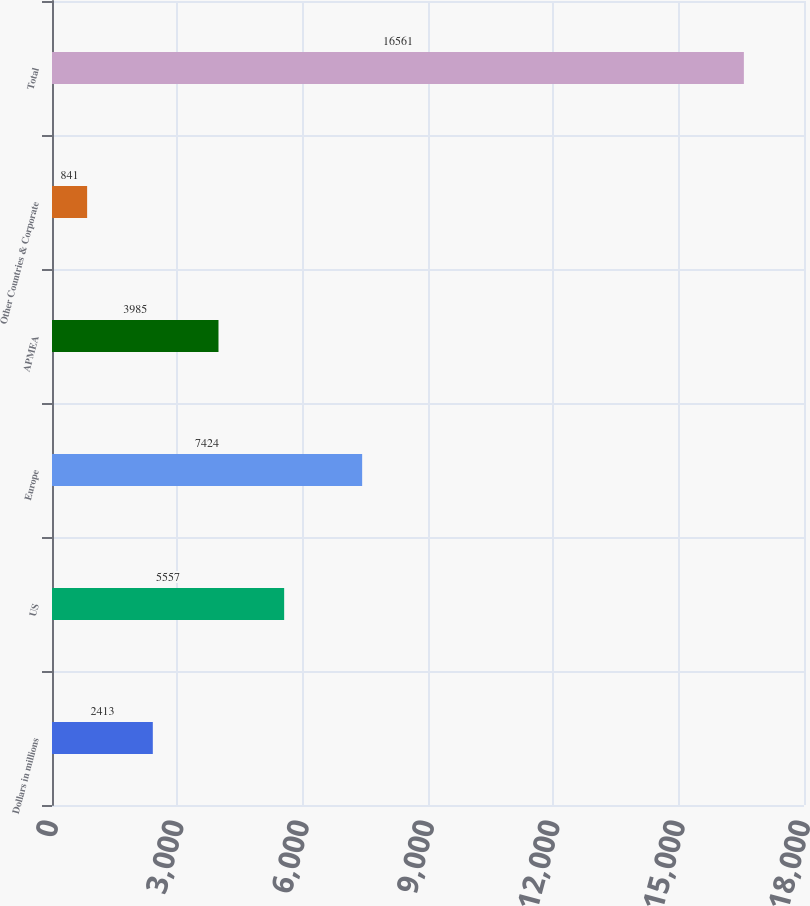Convert chart. <chart><loc_0><loc_0><loc_500><loc_500><bar_chart><fcel>Dollars in millions<fcel>US<fcel>Europe<fcel>APMEA<fcel>Other Countries & Corporate<fcel>Total<nl><fcel>2413<fcel>5557<fcel>7424<fcel>3985<fcel>841<fcel>16561<nl></chart> 